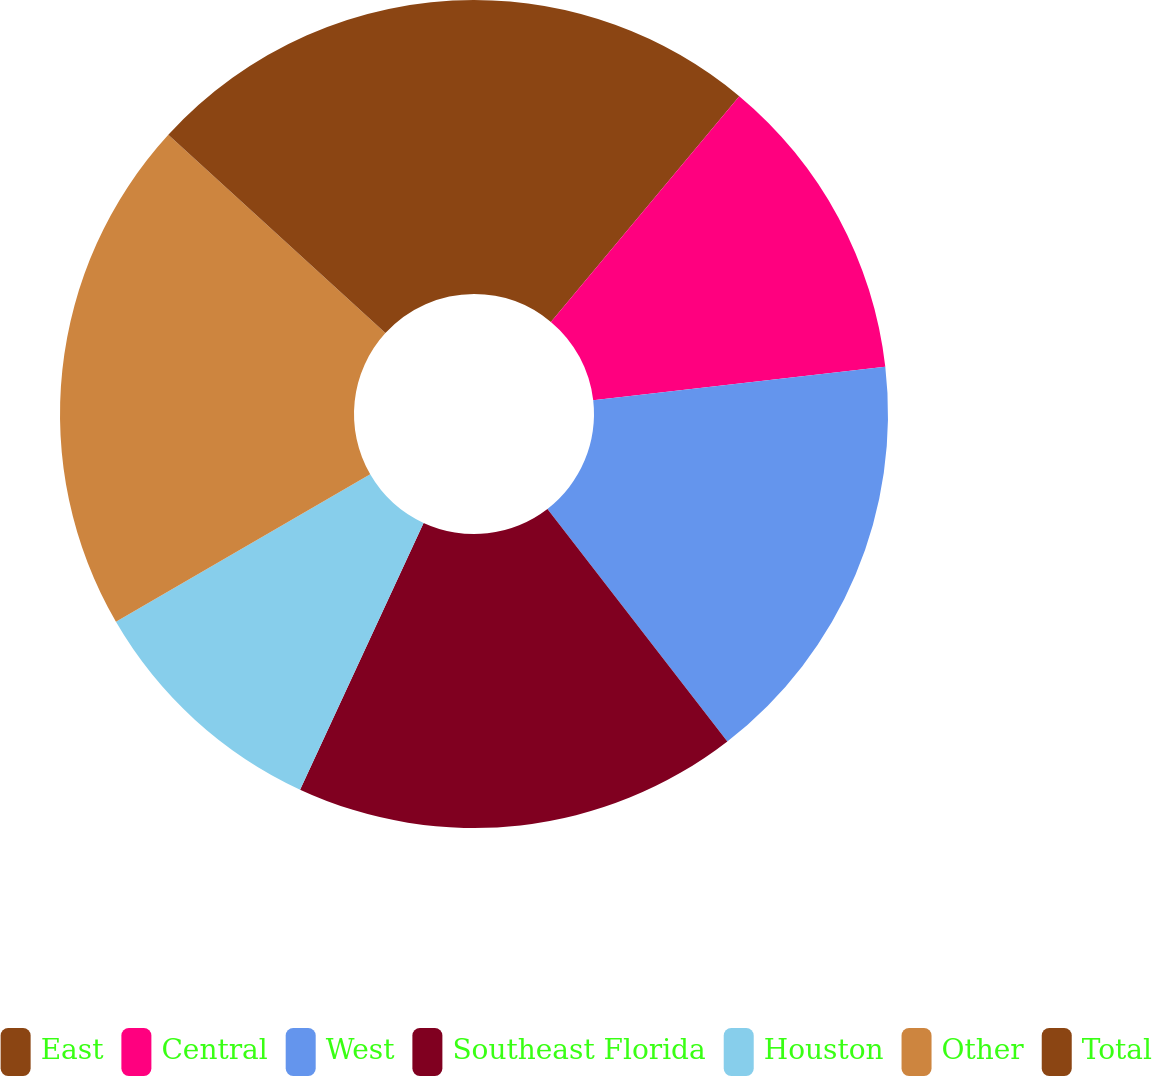Convert chart. <chart><loc_0><loc_0><loc_500><loc_500><pie_chart><fcel>East<fcel>Central<fcel>West<fcel>Southeast Florida<fcel>Houston<fcel>Other<fcel>Total<nl><fcel>11.07%<fcel>12.11%<fcel>16.34%<fcel>17.38%<fcel>9.73%<fcel>20.15%<fcel>13.22%<nl></chart> 